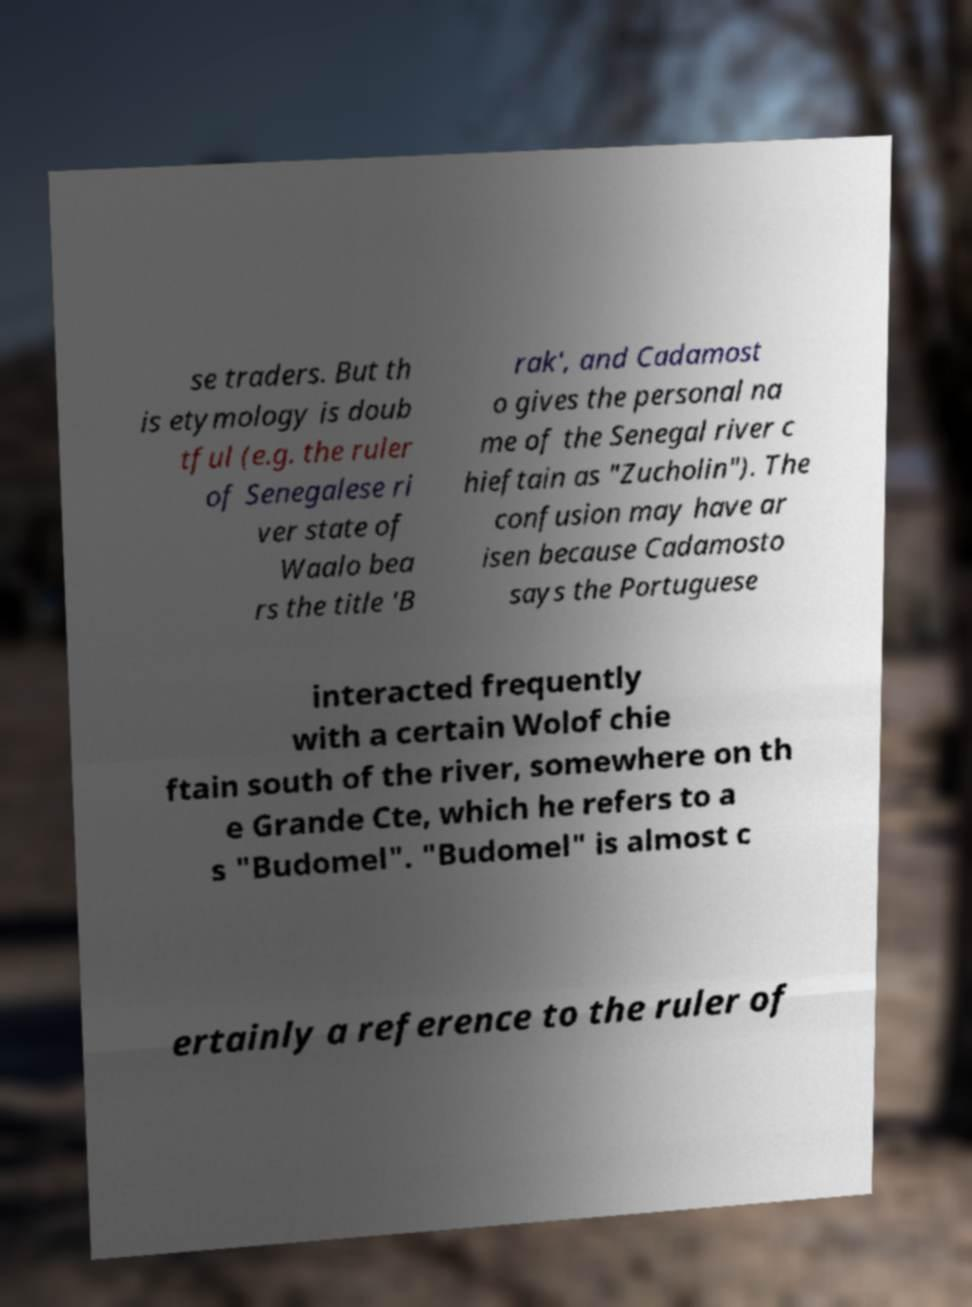I need the written content from this picture converted into text. Can you do that? se traders. But th is etymology is doub tful (e.g. the ruler of Senegalese ri ver state of Waalo bea rs the title 'B rak', and Cadamost o gives the personal na me of the Senegal river c hieftain as "Zucholin"). The confusion may have ar isen because Cadamosto says the Portuguese interacted frequently with a certain Wolof chie ftain south of the river, somewhere on th e Grande Cte, which he refers to a s "Budomel". "Budomel" is almost c ertainly a reference to the ruler of 